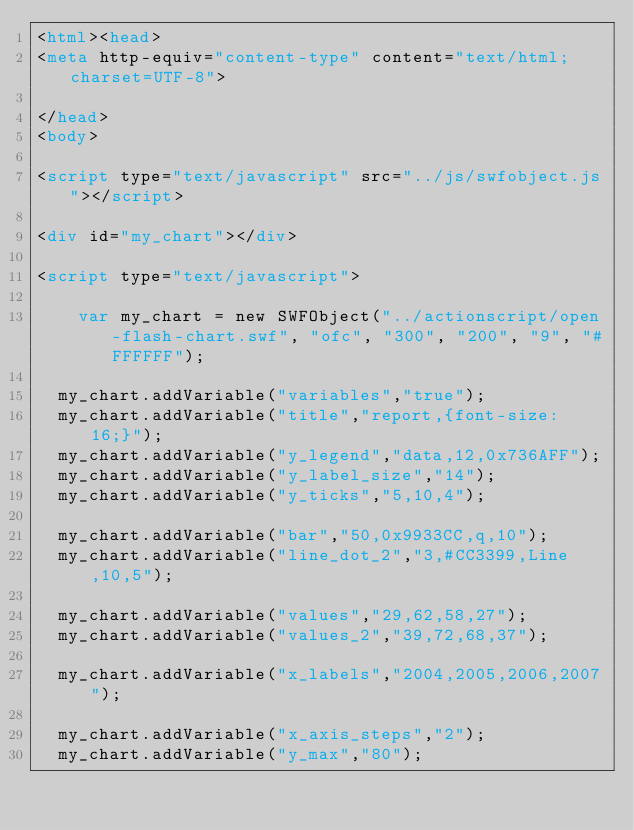<code> <loc_0><loc_0><loc_500><loc_500><_HTML_><html><head>
<meta http-equiv="content-type" content="text/html; charset=UTF-8">

</head>
<body>
    
<script type="text/javascript" src="../js/swfobject.js"></script>

<div id="my_chart"></div>
 	
<script type="text/javascript">

    var my_chart = new SWFObject("../actionscript/open-flash-chart.swf", "ofc", "300", "200", "9", "#FFFFFF");
	
	my_chart.addVariable("variables","true");
	my_chart.addVariable("title","report,{font-size: 16;}");
	my_chart.addVariable("y_legend","data,12,0x736AFF");
	my_chart.addVariable("y_label_size","14");
	my_chart.addVariable("y_ticks","5,10,4");
	
	my_chart.addVariable("bar","50,0x9933CC,q,10");
	my_chart.addVariable("line_dot_2","3,#CC3399,Line,10,5");
	
	my_chart.addVariable("values","29,62,58,27");
	my_chart.addVariable("values_2","39,72,68,37");
	
	my_chart.addVariable("x_labels","2004,2005,2006,2007");
				
	my_chart.addVariable("x_axis_steps","2");
	my_chart.addVariable("y_max","80");</code> 